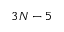<formula> <loc_0><loc_0><loc_500><loc_500>3 N - 5</formula> 